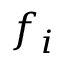Convert formula to latex. <formula><loc_0><loc_0><loc_500><loc_500>f _ { i }</formula> 